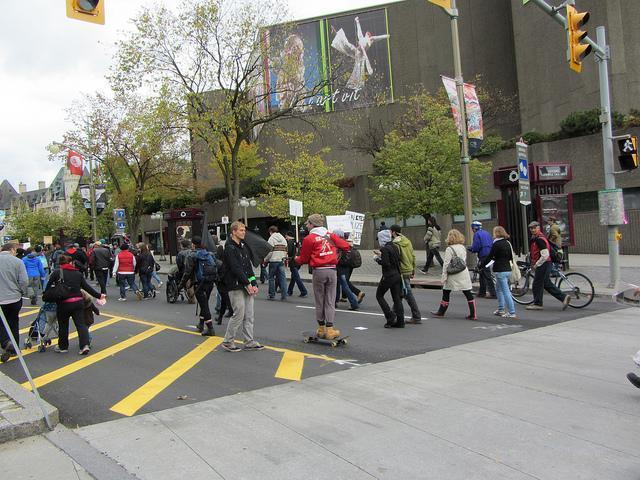How many bicycles are shown?
Give a very brief answer. 1. How many bikes?
Give a very brief answer. 1. How many people are sitting?
Give a very brief answer. 0. How many people are visible?
Give a very brief answer. 6. 